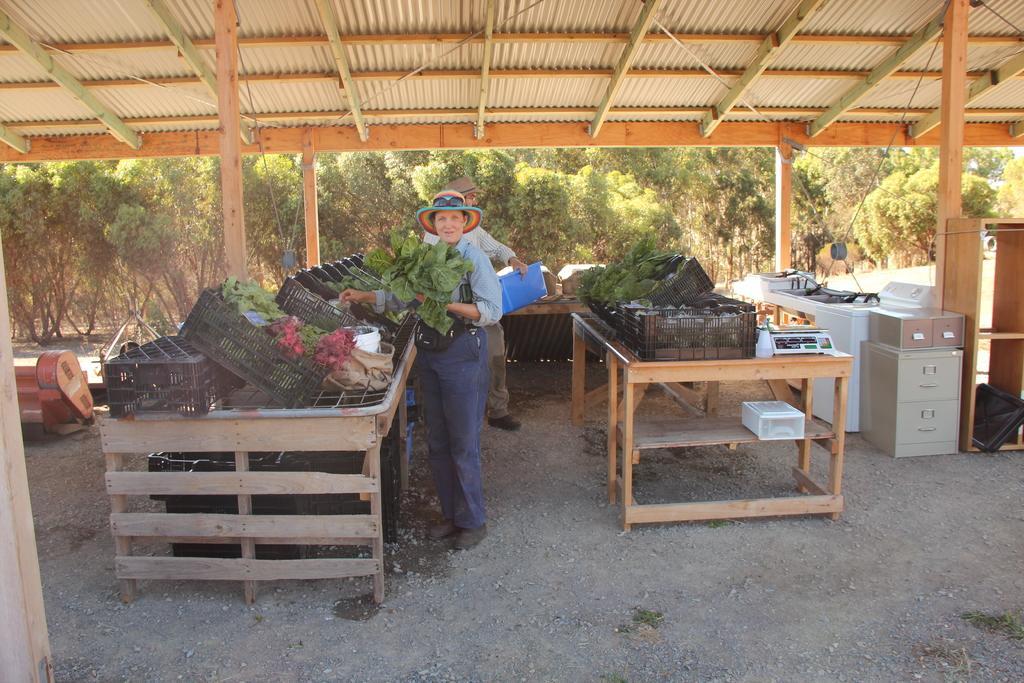Could you give a brief overview of what you see in this image? Under this roof there are two people and the woman is holding leafy vegetables and the person is holding a file. We can see plenty of vegetable baskets on the tables. In the background there are trees. On the right there are some cupboards and tables. 